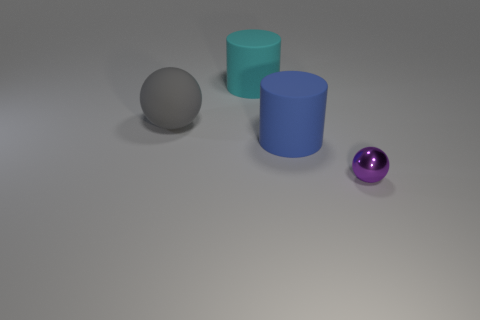Add 2 rubber cylinders. How many objects exist? 6 Subtract 0 red spheres. How many objects are left? 4 Subtract all small balls. Subtract all small blue objects. How many objects are left? 3 Add 2 purple spheres. How many purple spheres are left? 3 Add 3 big blue cylinders. How many big blue cylinders exist? 4 